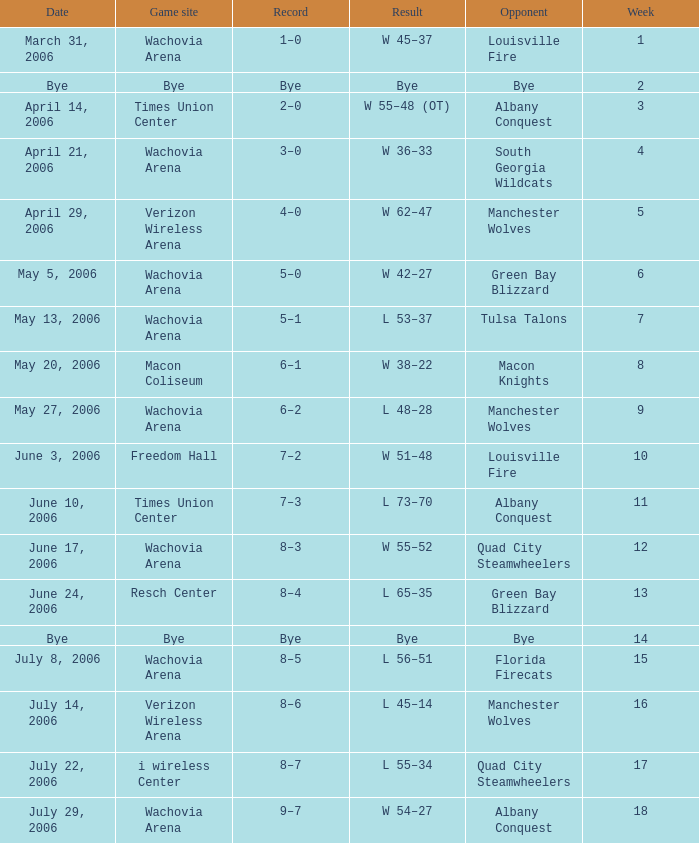Could you parse the entire table? {'header': ['Date', 'Game site', 'Record', 'Result', 'Opponent', 'Week'], 'rows': [['March 31, 2006', 'Wachovia Arena', '1–0', 'W 45–37', 'Louisville Fire', '1'], ['Bye', 'Bye', 'Bye', 'Bye', 'Bye', '2'], ['April 14, 2006', 'Times Union Center', '2–0', 'W 55–48 (OT)', 'Albany Conquest', '3'], ['April 21, 2006', 'Wachovia Arena', '3–0', 'W 36–33', 'South Georgia Wildcats', '4'], ['April 29, 2006', 'Verizon Wireless Arena', '4–0', 'W 62–47', 'Manchester Wolves', '5'], ['May 5, 2006', 'Wachovia Arena', '5–0', 'W 42–27', 'Green Bay Blizzard', '6'], ['May 13, 2006', 'Wachovia Arena', '5–1', 'L 53–37', 'Tulsa Talons', '7'], ['May 20, 2006', 'Macon Coliseum', '6–1', 'W 38–22', 'Macon Knights', '8'], ['May 27, 2006', 'Wachovia Arena', '6–2', 'L 48–28', 'Manchester Wolves', '9'], ['June 3, 2006', 'Freedom Hall', '7–2', 'W 51–48', 'Louisville Fire', '10'], ['June 10, 2006', 'Times Union Center', '7–3', 'L 73–70', 'Albany Conquest', '11'], ['June 17, 2006', 'Wachovia Arena', '8–3', 'W 55–52', 'Quad City Steamwheelers', '12'], ['June 24, 2006', 'Resch Center', '8–4', 'L 65–35', 'Green Bay Blizzard', '13'], ['Bye', 'Bye', 'Bye', 'Bye', 'Bye', '14'], ['July 8, 2006', 'Wachovia Arena', '8–5', 'L 56–51', 'Florida Firecats', '15'], ['July 14, 2006', 'Verizon Wireless Arena', '8–6', 'L 45–14', 'Manchester Wolves', '16'], ['July 22, 2006', 'i wireless Center', '8–7', 'L 55–34', 'Quad City Steamwheelers', '17'], ['July 29, 2006', 'Wachovia Arena', '9–7', 'W 54–27', 'Albany Conquest', '18']]} What is the Game site week 1? Wachovia Arena. 